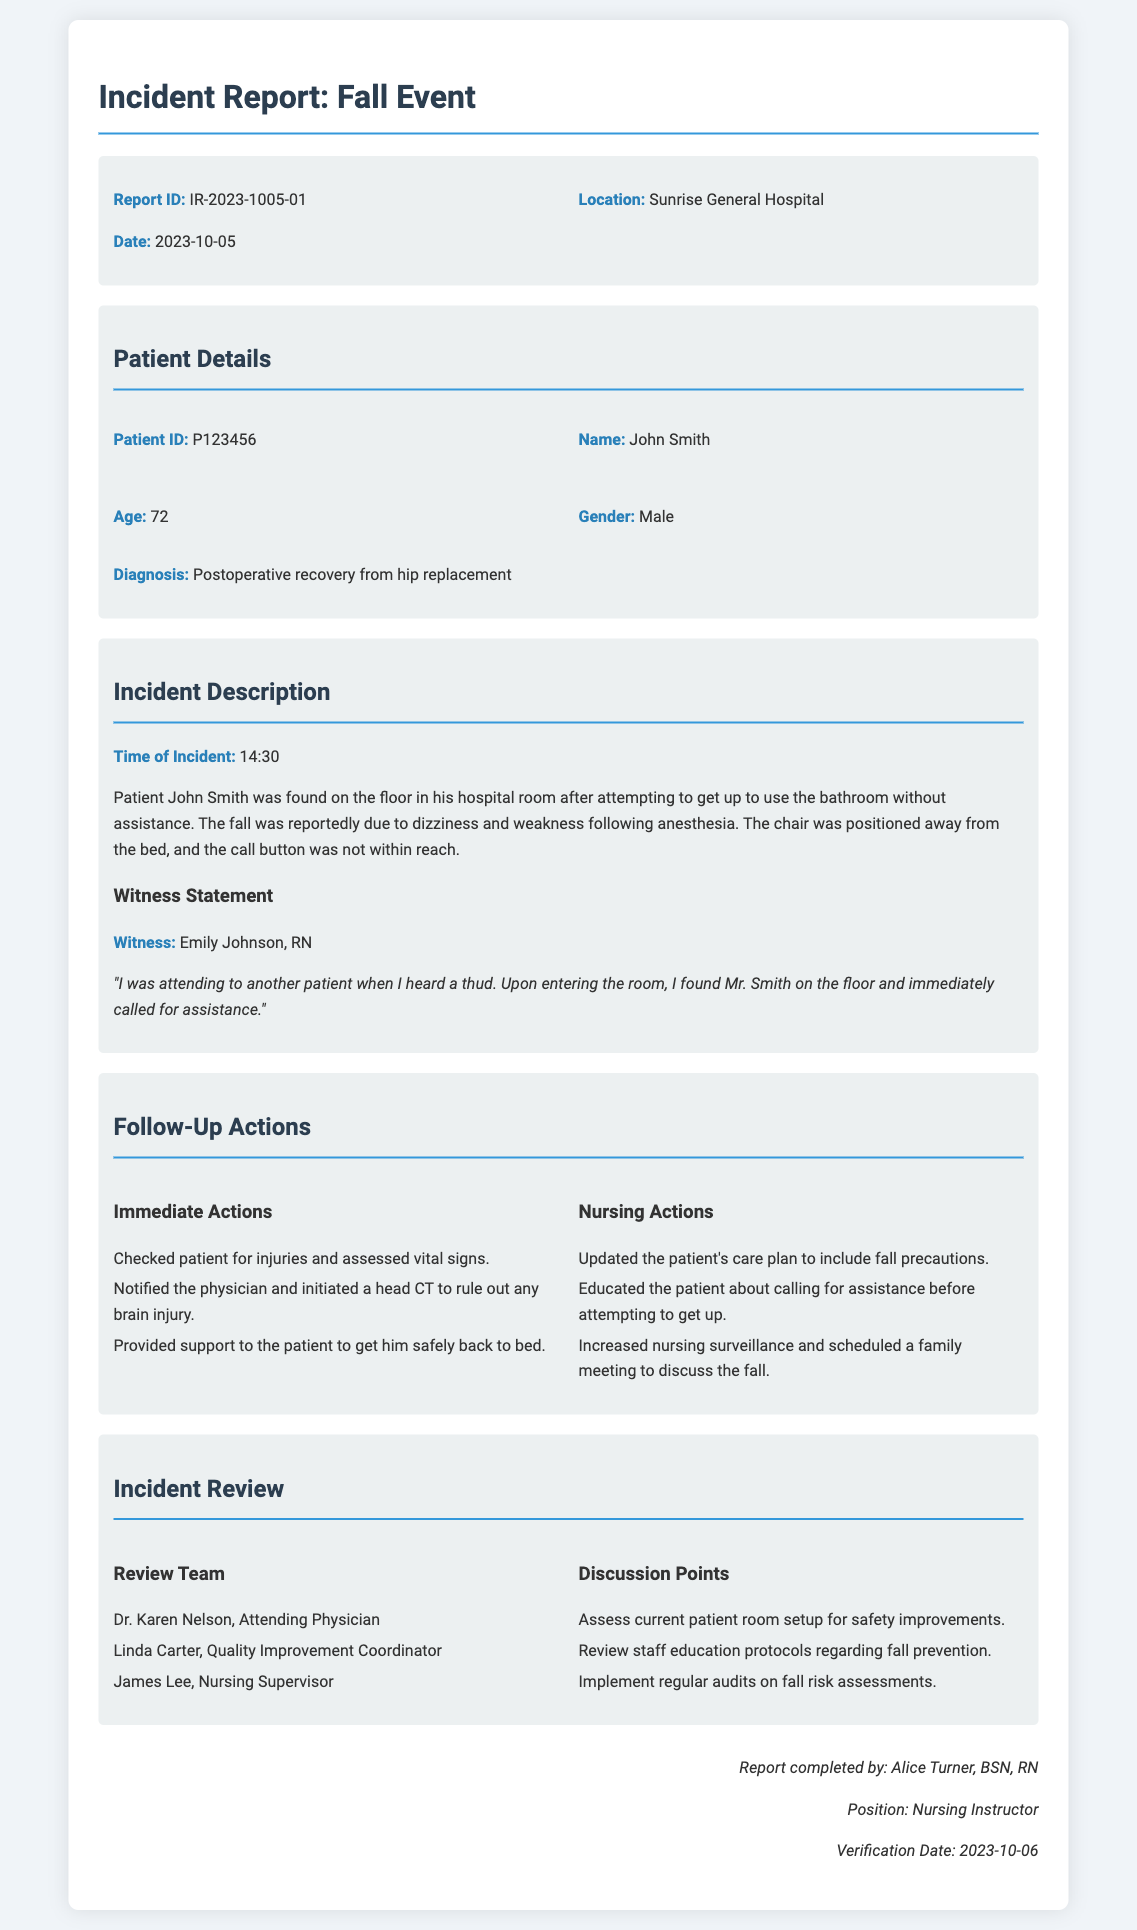What is the Report ID? The Report ID can be found in the header section of the document.
Answer: IR-2023-1005-01 What is the date of the incident? The date of the incident is clearly stated in the report under the date section.
Answer: 2023-10-05 Who is the patient? The patient's name is provided in the Patient Details section.
Answer: John Smith What was the time of the incident? The time of the incident is mentioned in the Incident Description section.
Answer: 14:30 What follow-up action was taken immediately? The immediate actions are listed in the Follow-Up Actions section, specifically detailing what was done right after the fall.
Answer: Checked patient for injuries and assessed vital signs Who was the witness to the incident? The witness statement includes the name of the person who witnessed the incident.
Answer: Emily Johnson, RN What was the patient's diagnosis? The patient's diagnosis is noted in the Patient Details section of the document.
Answer: Postoperative recovery from hip replacement What actions were included in the nursing follow-up? The nursing actions are outlined in the Follow-Up Actions section, highlighting steps taken post-incident.
Answer: Updated the patient's care plan to include fall precautions Who completed the report? The person's name who completed the report is noted at the end of the document.
Answer: Alice Turner, BSN, RN 